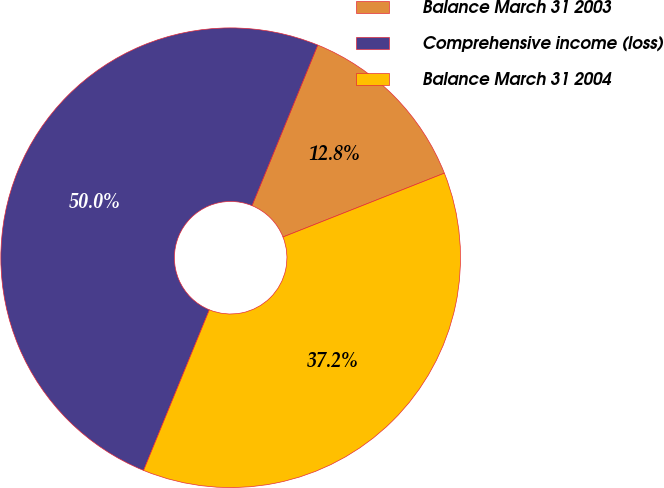Convert chart. <chart><loc_0><loc_0><loc_500><loc_500><pie_chart><fcel>Balance March 31 2003<fcel>Comprehensive income (loss)<fcel>Balance March 31 2004<nl><fcel>12.82%<fcel>50.0%<fcel>37.18%<nl></chart> 